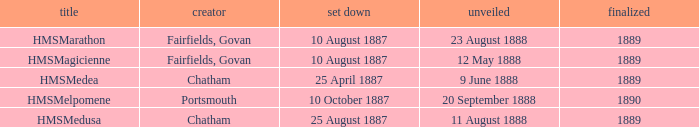Which builder completed after 1889? Portsmouth. 